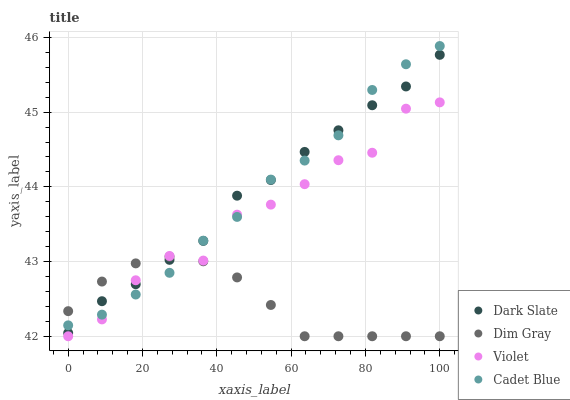Does Dim Gray have the minimum area under the curve?
Answer yes or no. Yes. Does Dark Slate have the maximum area under the curve?
Answer yes or no. Yes. Does Dark Slate have the minimum area under the curve?
Answer yes or no. No. Does Dim Gray have the maximum area under the curve?
Answer yes or no. No. Is Dim Gray the smoothest?
Answer yes or no. Yes. Is Violet the roughest?
Answer yes or no. Yes. Is Dark Slate the smoothest?
Answer yes or no. No. Is Dark Slate the roughest?
Answer yes or no. No. Does Dim Gray have the lowest value?
Answer yes or no. Yes. Does Dark Slate have the lowest value?
Answer yes or no. No. Does Cadet Blue have the highest value?
Answer yes or no. Yes. Does Dark Slate have the highest value?
Answer yes or no. No. Does Dark Slate intersect Violet?
Answer yes or no. Yes. Is Dark Slate less than Violet?
Answer yes or no. No. Is Dark Slate greater than Violet?
Answer yes or no. No. 